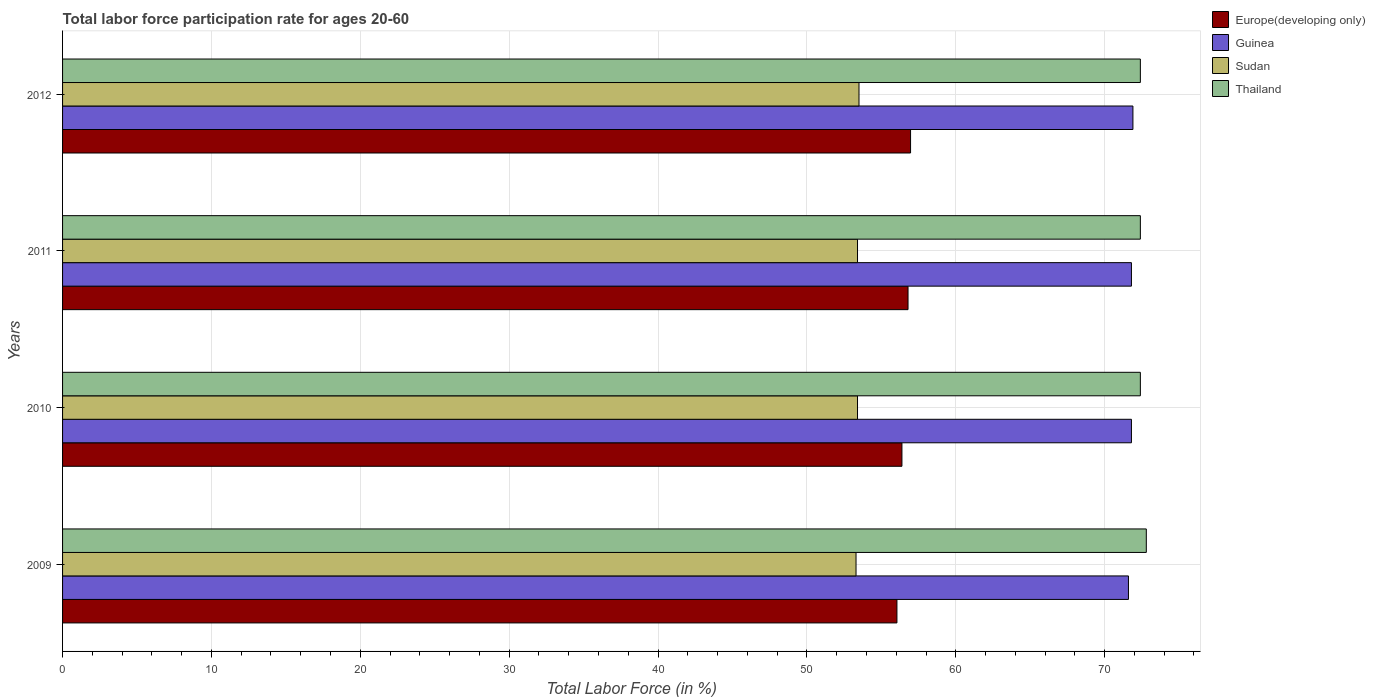Are the number of bars on each tick of the Y-axis equal?
Give a very brief answer. Yes. How many bars are there on the 4th tick from the top?
Your response must be concise. 4. In how many cases, is the number of bars for a given year not equal to the number of legend labels?
Make the answer very short. 0. What is the labor force participation rate in Sudan in 2011?
Offer a very short reply. 53.4. Across all years, what is the maximum labor force participation rate in Europe(developing only)?
Provide a succinct answer. 56.96. Across all years, what is the minimum labor force participation rate in Sudan?
Offer a very short reply. 53.3. In which year was the labor force participation rate in Sudan minimum?
Your answer should be very brief. 2009. What is the total labor force participation rate in Thailand in the graph?
Provide a succinct answer. 290. What is the difference between the labor force participation rate in Europe(developing only) in 2009 and that in 2011?
Ensure brevity in your answer.  -0.74. What is the difference between the labor force participation rate in Europe(developing only) in 2011 and the labor force participation rate in Sudan in 2012?
Give a very brief answer. 3.29. What is the average labor force participation rate in Thailand per year?
Offer a very short reply. 72.5. In the year 2012, what is the difference between the labor force participation rate in Sudan and labor force participation rate in Guinea?
Offer a terse response. -18.4. In how many years, is the labor force participation rate in Europe(developing only) greater than 56 %?
Offer a terse response. 4. What is the ratio of the labor force participation rate in Europe(developing only) in 2011 to that in 2012?
Your answer should be compact. 1. Is the labor force participation rate in Guinea in 2011 less than that in 2012?
Ensure brevity in your answer.  Yes. What is the difference between the highest and the second highest labor force participation rate in Sudan?
Give a very brief answer. 0.1. What is the difference between the highest and the lowest labor force participation rate in Sudan?
Provide a succinct answer. 0.2. Is it the case that in every year, the sum of the labor force participation rate in Guinea and labor force participation rate in Europe(developing only) is greater than the sum of labor force participation rate in Sudan and labor force participation rate in Thailand?
Provide a succinct answer. No. What does the 4th bar from the top in 2009 represents?
Your answer should be compact. Europe(developing only). What does the 4th bar from the bottom in 2010 represents?
Provide a succinct answer. Thailand. Are the values on the major ticks of X-axis written in scientific E-notation?
Keep it short and to the point. No. Does the graph contain any zero values?
Your answer should be compact. No. Does the graph contain grids?
Provide a short and direct response. Yes. Where does the legend appear in the graph?
Your response must be concise. Top right. How are the legend labels stacked?
Provide a succinct answer. Vertical. What is the title of the graph?
Provide a short and direct response. Total labor force participation rate for ages 20-60. Does "Maldives" appear as one of the legend labels in the graph?
Your answer should be very brief. No. What is the label or title of the X-axis?
Provide a short and direct response. Total Labor Force (in %). What is the Total Labor Force (in %) in Europe(developing only) in 2009?
Provide a succinct answer. 56.05. What is the Total Labor Force (in %) in Guinea in 2009?
Your answer should be very brief. 71.6. What is the Total Labor Force (in %) of Sudan in 2009?
Make the answer very short. 53.3. What is the Total Labor Force (in %) in Thailand in 2009?
Give a very brief answer. 72.8. What is the Total Labor Force (in %) of Europe(developing only) in 2010?
Keep it short and to the point. 56.38. What is the Total Labor Force (in %) in Guinea in 2010?
Make the answer very short. 71.8. What is the Total Labor Force (in %) of Sudan in 2010?
Give a very brief answer. 53.4. What is the Total Labor Force (in %) of Thailand in 2010?
Provide a short and direct response. 72.4. What is the Total Labor Force (in %) in Europe(developing only) in 2011?
Offer a terse response. 56.79. What is the Total Labor Force (in %) in Guinea in 2011?
Keep it short and to the point. 71.8. What is the Total Labor Force (in %) of Sudan in 2011?
Keep it short and to the point. 53.4. What is the Total Labor Force (in %) in Thailand in 2011?
Make the answer very short. 72.4. What is the Total Labor Force (in %) of Europe(developing only) in 2012?
Provide a short and direct response. 56.96. What is the Total Labor Force (in %) in Guinea in 2012?
Give a very brief answer. 71.9. What is the Total Labor Force (in %) in Sudan in 2012?
Your answer should be very brief. 53.5. What is the Total Labor Force (in %) in Thailand in 2012?
Keep it short and to the point. 72.4. Across all years, what is the maximum Total Labor Force (in %) in Europe(developing only)?
Offer a terse response. 56.96. Across all years, what is the maximum Total Labor Force (in %) of Guinea?
Give a very brief answer. 71.9. Across all years, what is the maximum Total Labor Force (in %) of Sudan?
Give a very brief answer. 53.5. Across all years, what is the maximum Total Labor Force (in %) of Thailand?
Your answer should be compact. 72.8. Across all years, what is the minimum Total Labor Force (in %) of Europe(developing only)?
Ensure brevity in your answer.  56.05. Across all years, what is the minimum Total Labor Force (in %) of Guinea?
Your answer should be very brief. 71.6. Across all years, what is the minimum Total Labor Force (in %) in Sudan?
Your response must be concise. 53.3. Across all years, what is the minimum Total Labor Force (in %) of Thailand?
Offer a terse response. 72.4. What is the total Total Labor Force (in %) in Europe(developing only) in the graph?
Offer a terse response. 226.19. What is the total Total Labor Force (in %) of Guinea in the graph?
Your answer should be compact. 287.1. What is the total Total Labor Force (in %) in Sudan in the graph?
Provide a short and direct response. 213.6. What is the total Total Labor Force (in %) in Thailand in the graph?
Your answer should be very brief. 290. What is the difference between the Total Labor Force (in %) in Europe(developing only) in 2009 and that in 2010?
Give a very brief answer. -0.34. What is the difference between the Total Labor Force (in %) of Europe(developing only) in 2009 and that in 2011?
Offer a very short reply. -0.74. What is the difference between the Total Labor Force (in %) in Sudan in 2009 and that in 2011?
Offer a very short reply. -0.1. What is the difference between the Total Labor Force (in %) of Thailand in 2009 and that in 2011?
Offer a very short reply. 0.4. What is the difference between the Total Labor Force (in %) in Europe(developing only) in 2009 and that in 2012?
Your answer should be compact. -0.92. What is the difference between the Total Labor Force (in %) of Guinea in 2009 and that in 2012?
Give a very brief answer. -0.3. What is the difference between the Total Labor Force (in %) in Sudan in 2009 and that in 2012?
Give a very brief answer. -0.2. What is the difference between the Total Labor Force (in %) in Thailand in 2009 and that in 2012?
Offer a very short reply. 0.4. What is the difference between the Total Labor Force (in %) in Europe(developing only) in 2010 and that in 2011?
Make the answer very short. -0.41. What is the difference between the Total Labor Force (in %) in Guinea in 2010 and that in 2011?
Provide a succinct answer. 0. What is the difference between the Total Labor Force (in %) of Europe(developing only) in 2010 and that in 2012?
Keep it short and to the point. -0.58. What is the difference between the Total Labor Force (in %) in Thailand in 2010 and that in 2012?
Offer a very short reply. 0. What is the difference between the Total Labor Force (in %) in Europe(developing only) in 2011 and that in 2012?
Your answer should be very brief. -0.17. What is the difference between the Total Labor Force (in %) of Sudan in 2011 and that in 2012?
Keep it short and to the point. -0.1. What is the difference between the Total Labor Force (in %) of Thailand in 2011 and that in 2012?
Provide a short and direct response. 0. What is the difference between the Total Labor Force (in %) in Europe(developing only) in 2009 and the Total Labor Force (in %) in Guinea in 2010?
Your response must be concise. -15.75. What is the difference between the Total Labor Force (in %) in Europe(developing only) in 2009 and the Total Labor Force (in %) in Sudan in 2010?
Keep it short and to the point. 2.65. What is the difference between the Total Labor Force (in %) of Europe(developing only) in 2009 and the Total Labor Force (in %) of Thailand in 2010?
Your response must be concise. -16.35. What is the difference between the Total Labor Force (in %) of Sudan in 2009 and the Total Labor Force (in %) of Thailand in 2010?
Offer a terse response. -19.1. What is the difference between the Total Labor Force (in %) of Europe(developing only) in 2009 and the Total Labor Force (in %) of Guinea in 2011?
Give a very brief answer. -15.75. What is the difference between the Total Labor Force (in %) of Europe(developing only) in 2009 and the Total Labor Force (in %) of Sudan in 2011?
Your response must be concise. 2.65. What is the difference between the Total Labor Force (in %) of Europe(developing only) in 2009 and the Total Labor Force (in %) of Thailand in 2011?
Offer a very short reply. -16.35. What is the difference between the Total Labor Force (in %) of Guinea in 2009 and the Total Labor Force (in %) of Sudan in 2011?
Make the answer very short. 18.2. What is the difference between the Total Labor Force (in %) of Guinea in 2009 and the Total Labor Force (in %) of Thailand in 2011?
Provide a succinct answer. -0.8. What is the difference between the Total Labor Force (in %) in Sudan in 2009 and the Total Labor Force (in %) in Thailand in 2011?
Keep it short and to the point. -19.1. What is the difference between the Total Labor Force (in %) of Europe(developing only) in 2009 and the Total Labor Force (in %) of Guinea in 2012?
Your response must be concise. -15.85. What is the difference between the Total Labor Force (in %) in Europe(developing only) in 2009 and the Total Labor Force (in %) in Sudan in 2012?
Offer a very short reply. 2.55. What is the difference between the Total Labor Force (in %) in Europe(developing only) in 2009 and the Total Labor Force (in %) in Thailand in 2012?
Give a very brief answer. -16.35. What is the difference between the Total Labor Force (in %) in Guinea in 2009 and the Total Labor Force (in %) in Sudan in 2012?
Offer a very short reply. 18.1. What is the difference between the Total Labor Force (in %) of Sudan in 2009 and the Total Labor Force (in %) of Thailand in 2012?
Make the answer very short. -19.1. What is the difference between the Total Labor Force (in %) of Europe(developing only) in 2010 and the Total Labor Force (in %) of Guinea in 2011?
Your response must be concise. -15.42. What is the difference between the Total Labor Force (in %) of Europe(developing only) in 2010 and the Total Labor Force (in %) of Sudan in 2011?
Your response must be concise. 2.98. What is the difference between the Total Labor Force (in %) of Europe(developing only) in 2010 and the Total Labor Force (in %) of Thailand in 2011?
Provide a succinct answer. -16.02. What is the difference between the Total Labor Force (in %) in Europe(developing only) in 2010 and the Total Labor Force (in %) in Guinea in 2012?
Your response must be concise. -15.52. What is the difference between the Total Labor Force (in %) of Europe(developing only) in 2010 and the Total Labor Force (in %) of Sudan in 2012?
Give a very brief answer. 2.88. What is the difference between the Total Labor Force (in %) of Europe(developing only) in 2010 and the Total Labor Force (in %) of Thailand in 2012?
Give a very brief answer. -16.02. What is the difference between the Total Labor Force (in %) in Guinea in 2010 and the Total Labor Force (in %) in Sudan in 2012?
Your response must be concise. 18.3. What is the difference between the Total Labor Force (in %) of Europe(developing only) in 2011 and the Total Labor Force (in %) of Guinea in 2012?
Ensure brevity in your answer.  -15.11. What is the difference between the Total Labor Force (in %) in Europe(developing only) in 2011 and the Total Labor Force (in %) in Sudan in 2012?
Your answer should be very brief. 3.29. What is the difference between the Total Labor Force (in %) in Europe(developing only) in 2011 and the Total Labor Force (in %) in Thailand in 2012?
Offer a terse response. -15.61. What is the difference between the Total Labor Force (in %) of Guinea in 2011 and the Total Labor Force (in %) of Sudan in 2012?
Keep it short and to the point. 18.3. What is the average Total Labor Force (in %) in Europe(developing only) per year?
Provide a short and direct response. 56.55. What is the average Total Labor Force (in %) in Guinea per year?
Keep it short and to the point. 71.78. What is the average Total Labor Force (in %) of Sudan per year?
Offer a terse response. 53.4. What is the average Total Labor Force (in %) of Thailand per year?
Offer a terse response. 72.5. In the year 2009, what is the difference between the Total Labor Force (in %) in Europe(developing only) and Total Labor Force (in %) in Guinea?
Give a very brief answer. -15.55. In the year 2009, what is the difference between the Total Labor Force (in %) of Europe(developing only) and Total Labor Force (in %) of Sudan?
Your answer should be very brief. 2.75. In the year 2009, what is the difference between the Total Labor Force (in %) in Europe(developing only) and Total Labor Force (in %) in Thailand?
Keep it short and to the point. -16.75. In the year 2009, what is the difference between the Total Labor Force (in %) in Guinea and Total Labor Force (in %) in Sudan?
Your response must be concise. 18.3. In the year 2009, what is the difference between the Total Labor Force (in %) of Sudan and Total Labor Force (in %) of Thailand?
Provide a succinct answer. -19.5. In the year 2010, what is the difference between the Total Labor Force (in %) of Europe(developing only) and Total Labor Force (in %) of Guinea?
Keep it short and to the point. -15.42. In the year 2010, what is the difference between the Total Labor Force (in %) in Europe(developing only) and Total Labor Force (in %) in Sudan?
Keep it short and to the point. 2.98. In the year 2010, what is the difference between the Total Labor Force (in %) in Europe(developing only) and Total Labor Force (in %) in Thailand?
Your response must be concise. -16.02. In the year 2010, what is the difference between the Total Labor Force (in %) of Guinea and Total Labor Force (in %) of Sudan?
Provide a succinct answer. 18.4. In the year 2011, what is the difference between the Total Labor Force (in %) of Europe(developing only) and Total Labor Force (in %) of Guinea?
Offer a very short reply. -15.01. In the year 2011, what is the difference between the Total Labor Force (in %) in Europe(developing only) and Total Labor Force (in %) in Sudan?
Keep it short and to the point. 3.39. In the year 2011, what is the difference between the Total Labor Force (in %) of Europe(developing only) and Total Labor Force (in %) of Thailand?
Your response must be concise. -15.61. In the year 2011, what is the difference between the Total Labor Force (in %) in Sudan and Total Labor Force (in %) in Thailand?
Ensure brevity in your answer.  -19. In the year 2012, what is the difference between the Total Labor Force (in %) of Europe(developing only) and Total Labor Force (in %) of Guinea?
Your answer should be compact. -14.94. In the year 2012, what is the difference between the Total Labor Force (in %) of Europe(developing only) and Total Labor Force (in %) of Sudan?
Give a very brief answer. 3.46. In the year 2012, what is the difference between the Total Labor Force (in %) of Europe(developing only) and Total Labor Force (in %) of Thailand?
Provide a short and direct response. -15.44. In the year 2012, what is the difference between the Total Labor Force (in %) in Guinea and Total Labor Force (in %) in Thailand?
Your response must be concise. -0.5. In the year 2012, what is the difference between the Total Labor Force (in %) in Sudan and Total Labor Force (in %) in Thailand?
Offer a very short reply. -18.9. What is the ratio of the Total Labor Force (in %) of Guinea in 2009 to that in 2010?
Your response must be concise. 1. What is the ratio of the Total Labor Force (in %) in Sudan in 2009 to that in 2010?
Give a very brief answer. 1. What is the ratio of the Total Labor Force (in %) in Europe(developing only) in 2009 to that in 2011?
Keep it short and to the point. 0.99. What is the ratio of the Total Labor Force (in %) of Europe(developing only) in 2009 to that in 2012?
Your answer should be very brief. 0.98. What is the ratio of the Total Labor Force (in %) of Guinea in 2009 to that in 2012?
Offer a terse response. 1. What is the ratio of the Total Labor Force (in %) of Sudan in 2009 to that in 2012?
Your response must be concise. 1. What is the ratio of the Total Labor Force (in %) of Thailand in 2009 to that in 2012?
Your response must be concise. 1.01. What is the ratio of the Total Labor Force (in %) of Sudan in 2010 to that in 2011?
Your answer should be very brief. 1. What is the ratio of the Total Labor Force (in %) in Thailand in 2010 to that in 2011?
Offer a very short reply. 1. What is the ratio of the Total Labor Force (in %) of Europe(developing only) in 2010 to that in 2012?
Offer a very short reply. 0.99. What is the ratio of the Total Labor Force (in %) in Guinea in 2010 to that in 2012?
Your answer should be very brief. 1. What is the ratio of the Total Labor Force (in %) of Sudan in 2010 to that in 2012?
Make the answer very short. 1. What is the ratio of the Total Labor Force (in %) in Guinea in 2011 to that in 2012?
Offer a terse response. 1. What is the difference between the highest and the second highest Total Labor Force (in %) of Europe(developing only)?
Your answer should be compact. 0.17. What is the difference between the highest and the second highest Total Labor Force (in %) in Guinea?
Ensure brevity in your answer.  0.1. What is the difference between the highest and the second highest Total Labor Force (in %) in Sudan?
Make the answer very short. 0.1. What is the difference between the highest and the second highest Total Labor Force (in %) of Thailand?
Provide a short and direct response. 0.4. What is the difference between the highest and the lowest Total Labor Force (in %) in Europe(developing only)?
Your response must be concise. 0.92. What is the difference between the highest and the lowest Total Labor Force (in %) in Sudan?
Your answer should be compact. 0.2. 